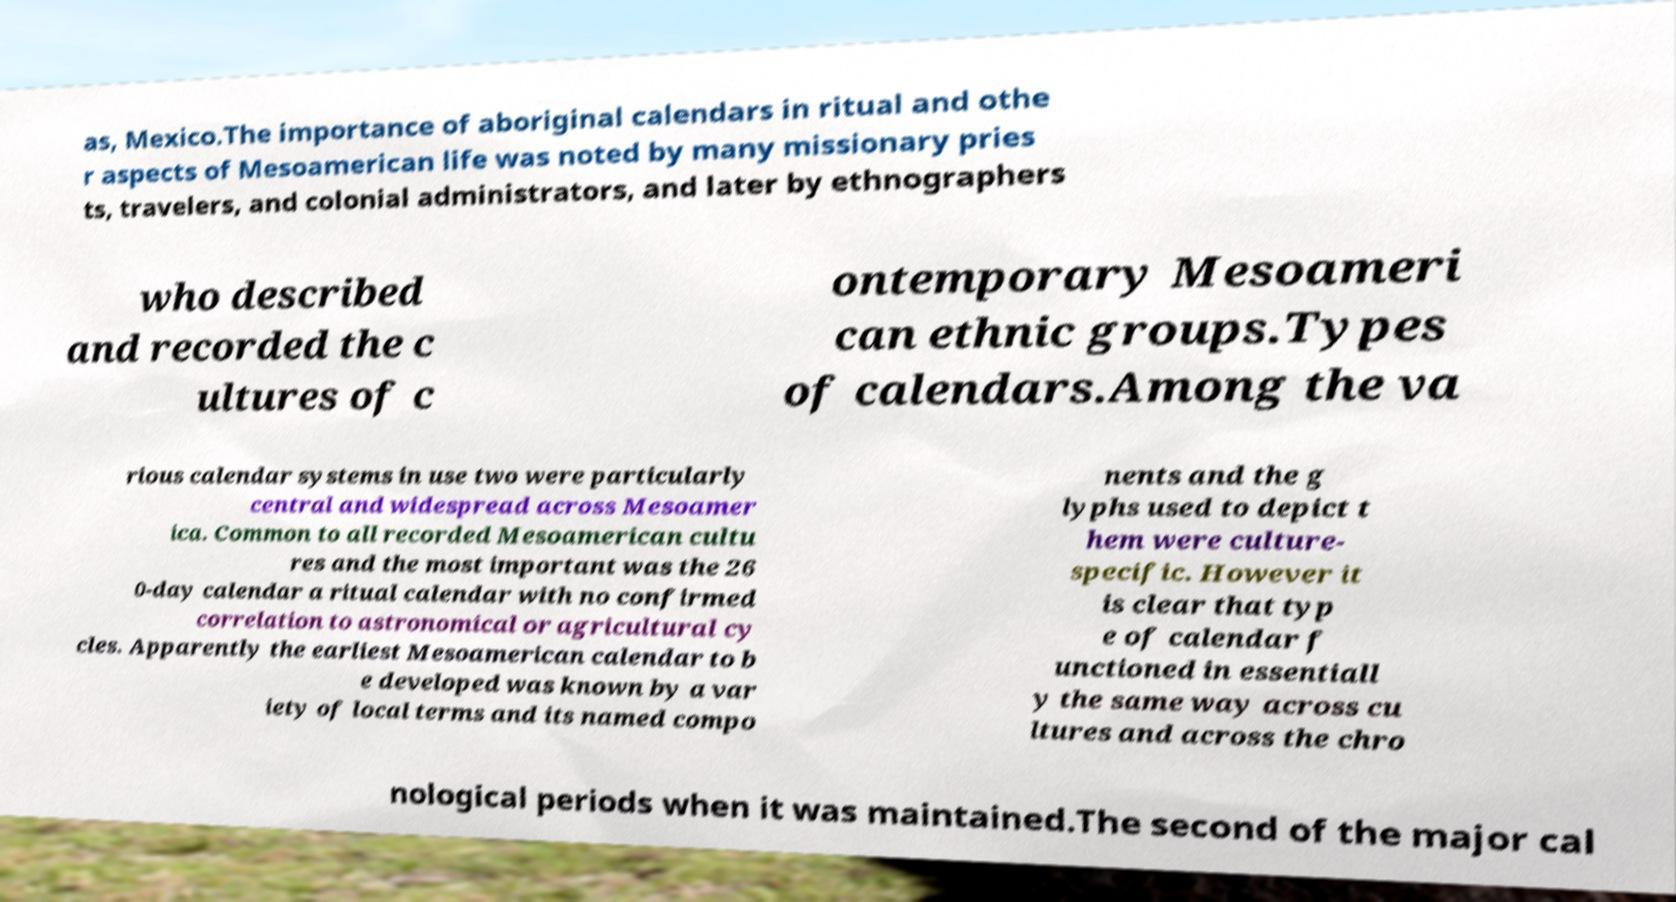For documentation purposes, I need the text within this image transcribed. Could you provide that? as, Mexico.The importance of aboriginal calendars in ritual and othe r aspects of Mesoamerican life was noted by many missionary pries ts, travelers, and colonial administrators, and later by ethnographers who described and recorded the c ultures of c ontemporary Mesoameri can ethnic groups.Types of calendars.Among the va rious calendar systems in use two were particularly central and widespread across Mesoamer ica. Common to all recorded Mesoamerican cultu res and the most important was the 26 0-day calendar a ritual calendar with no confirmed correlation to astronomical or agricultural cy cles. Apparently the earliest Mesoamerican calendar to b e developed was known by a var iety of local terms and its named compo nents and the g lyphs used to depict t hem were culture- specific. However it is clear that typ e of calendar f unctioned in essentiall y the same way across cu ltures and across the chro nological periods when it was maintained.The second of the major cal 